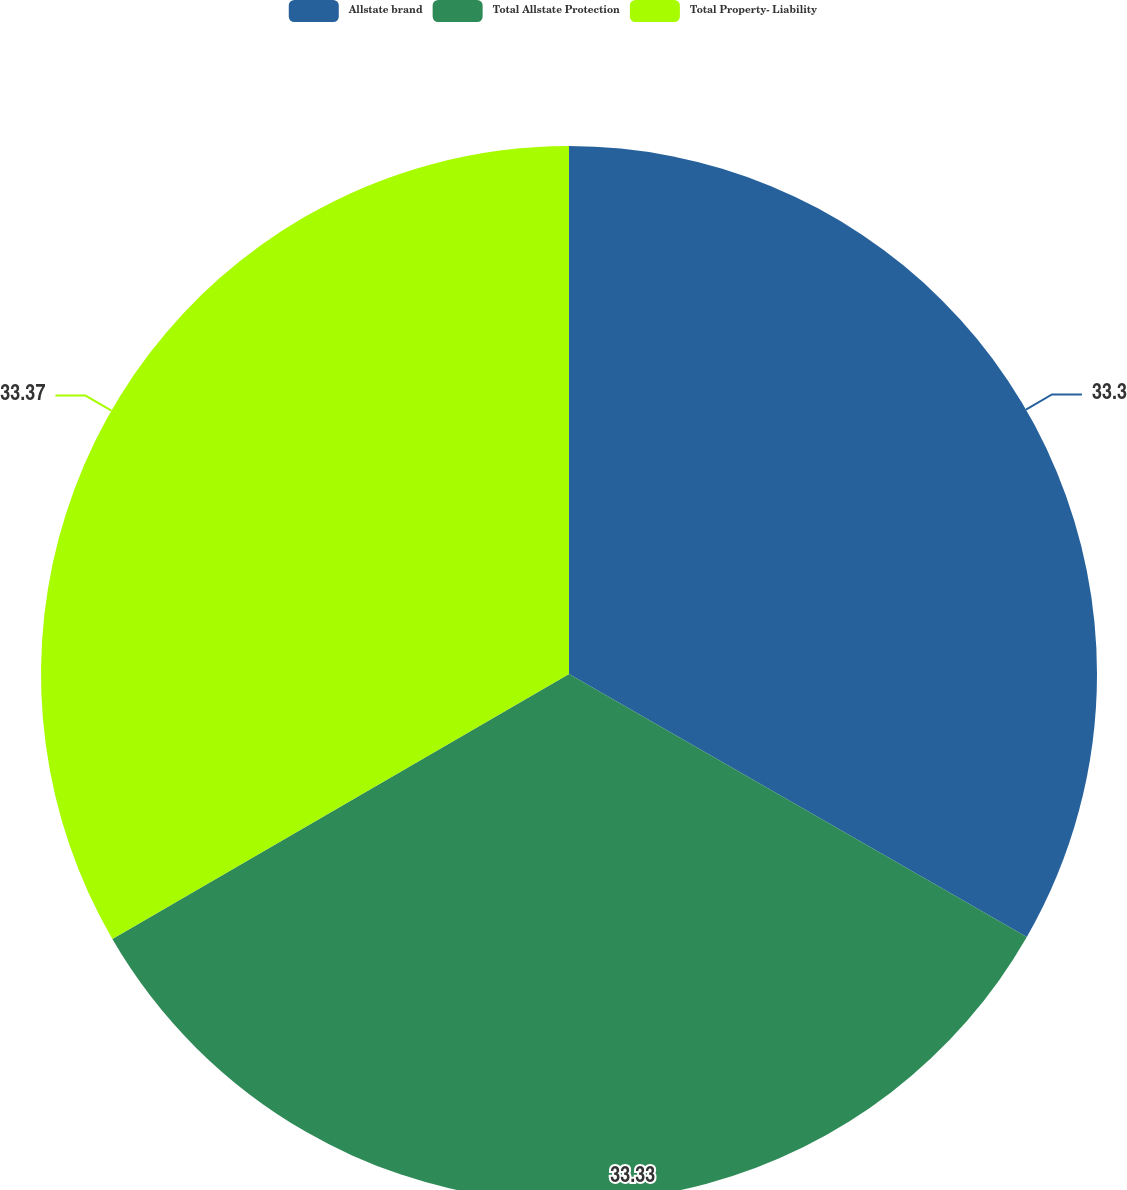Convert chart to OTSL. <chart><loc_0><loc_0><loc_500><loc_500><pie_chart><fcel>Allstate brand<fcel>Total Allstate Protection<fcel>Total Property- Liability<nl><fcel>33.3%<fcel>33.33%<fcel>33.37%<nl></chart> 